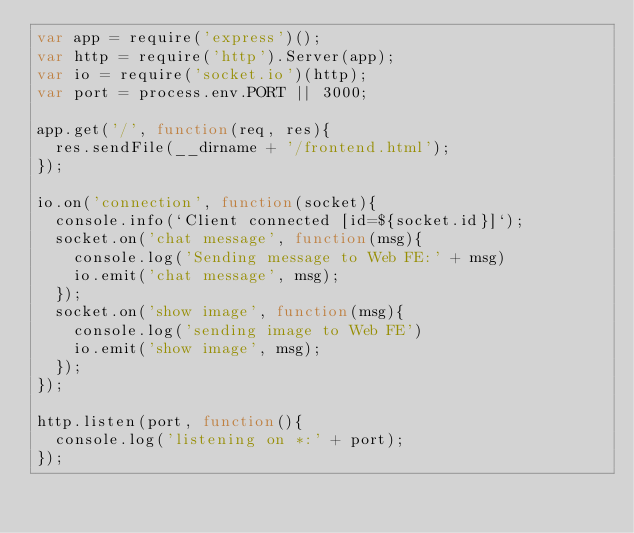Convert code to text. <code><loc_0><loc_0><loc_500><loc_500><_JavaScript_>var app = require('express')();
var http = require('http').Server(app);
var io = require('socket.io')(http);
var port = process.env.PORT || 3000;

app.get('/', function(req, res){
  res.sendFile(__dirname + '/frontend.html');
});

io.on('connection', function(socket){
  console.info(`Client connected [id=${socket.id}]`);
  socket.on('chat message', function(msg){
    console.log('Sending message to Web FE:' + msg)
    io.emit('chat message', msg);
  });
  socket.on('show image', function(msg){
    console.log('sending image to Web FE')
    io.emit('show image', msg);
  });
});

http.listen(port, function(){
  console.log('listening on *:' + port);
});</code> 